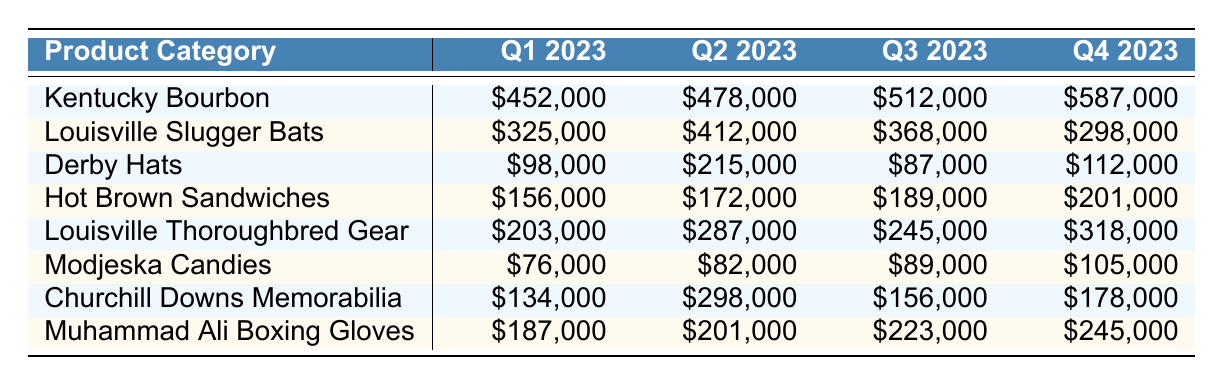What was the revenue for Kentucky Bourbon in Q3 2023? The table shows the revenue for Kentucky Bourbon in Q3 2023 as \$512,000.
Answer: \$512,000 Which product category had the highest revenue in Q4 2023? By examining the Q4 2023 column, Kentucky Bourbon has the highest revenue of \$587,000 compared to the other categories.
Answer: Kentucky Bourbon What is the total revenue for Louisville Slugger Bats across all quarters? The revenues for Louisville Slugger Bats are \$325,000, \$412,000, \$368,000, and \$298,000. Summing these gives \$325,000 + \$412,000 + \$368,000 + \$298,000 = \$1,403,000.
Answer: \$1,403,000 What is the average revenue from Derby Hats? The revenues are \$98,000, \$215,000, \$87,000, and \$112,000. The average is calculated as follows: (98 + 215 + 87 + 112) / 4 = 128. The average revenue from Derby Hats is \$128,000.
Answer: \$128,000 Did the revenue for Hot Brown Sandwiches increase in Q2 2023 compared to Q1 2023? The revenue for Hot Brown Sandwiches was \$156,000 in Q1 and increased to \$172,000 in Q2, which is an increase.
Answer: Yes Which product category showed the greatest increase in revenue from Q1 2023 to Q4 2023? Looking at the increase from Q1 to Q4 for each category, Kentucky Bourbon increased from \$452,000 to \$587,000, which is an increase of \$135,000, the highest among all categories.
Answer: Kentucky Bourbon What is the difference in revenue between Modjeska Candies in Q4 2023 and Q3 2023? The revenue for Modjeska Candies in Q3 2023 is \$89,000 and in Q4 2023 it is \$105,000. The difference is \$105,000 - \$89,000 = \$16,000.
Answer: \$16,000 What was the total revenue for Churchill Downs Memorabilia in Q3 2023 compared to Q2 2023? The revenue for Churchill Downs Memorabilia in Q2 2023 is \$298,000 and in Q3 2023 is \$156,000. The total for both quarters is \$298,000 + \$156,000 = \$454,000.
Answer: \$454,000 Is there any product category that generated more than \$300,000 in Q2 2023? In the Q2 2023 column, Kentucky Bourbon (\$478,000), Louisville Slugger Bats (\$412,000), and Churchill Downs Memorabilia (\$298,000) generated revenue above \$300,000, so the answer is yes.
Answer: Yes Which product category had the lowest revenue in Q1 2023? The table indicates that Modjeska Candies had the lowest revenue in Q1 2023 at \$76,000.
Answer: Modjeska Candies 